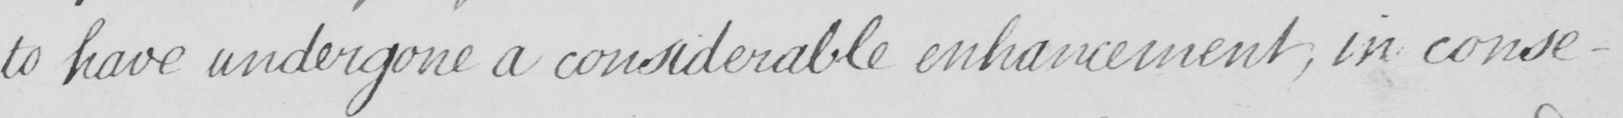Transcribe the text shown in this historical manuscript line. to have undergone a considerable enhancement ; in conse- 